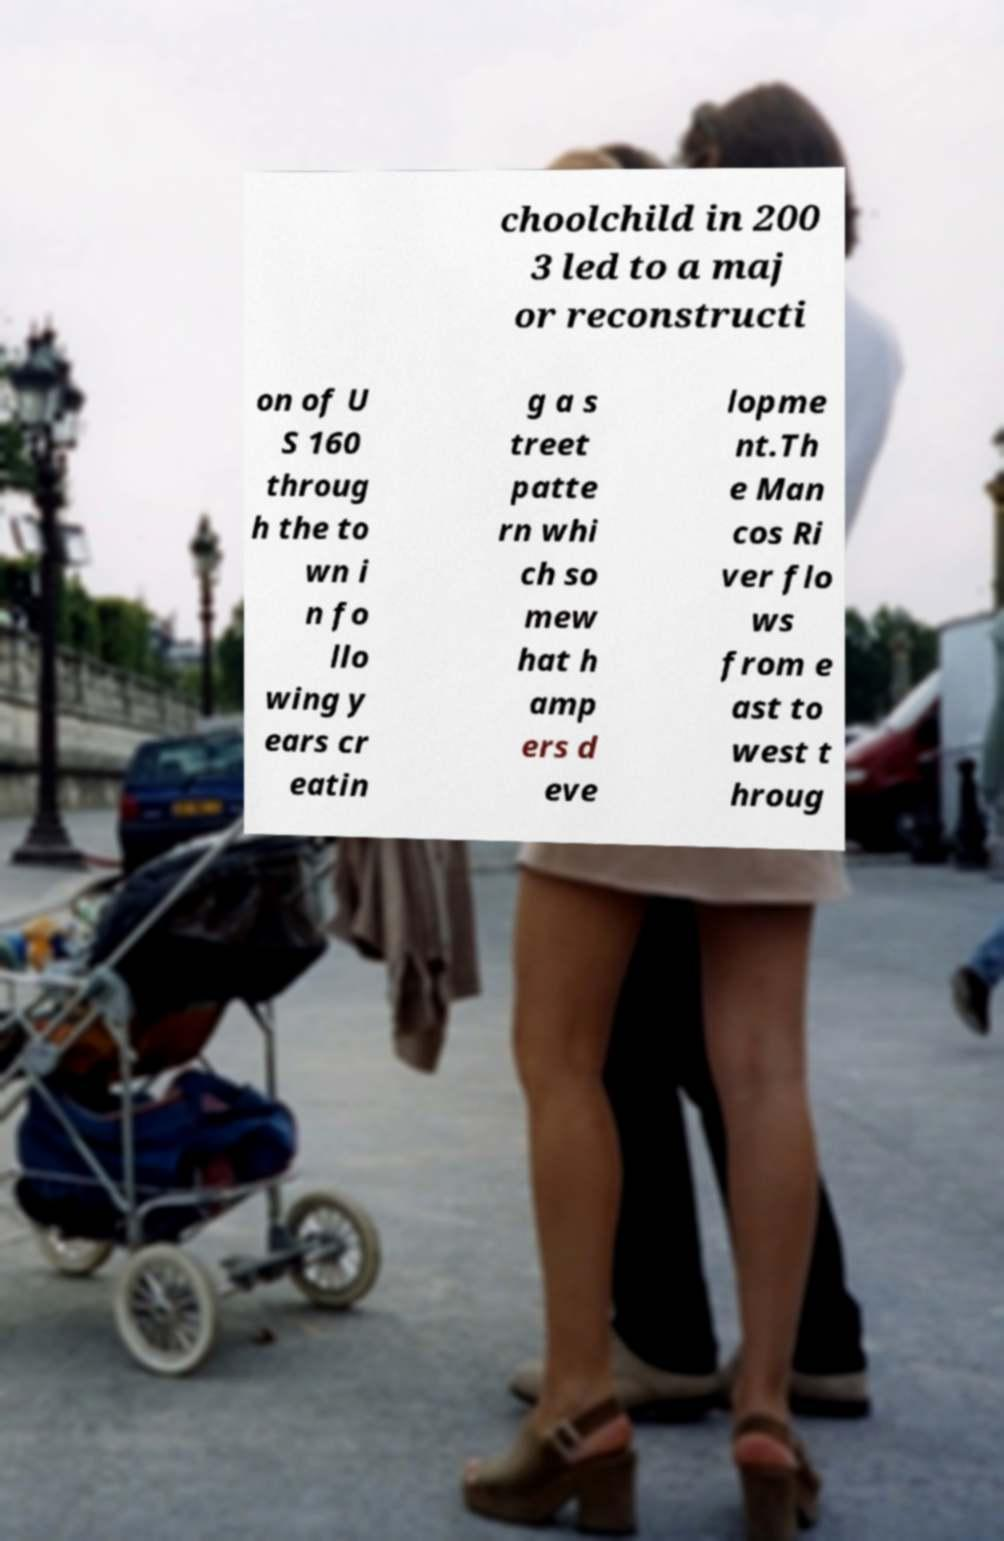What messages or text are displayed in this image? I need them in a readable, typed format. choolchild in 200 3 led to a maj or reconstructi on of U S 160 throug h the to wn i n fo llo wing y ears cr eatin g a s treet patte rn whi ch so mew hat h amp ers d eve lopme nt.Th e Man cos Ri ver flo ws from e ast to west t hroug 